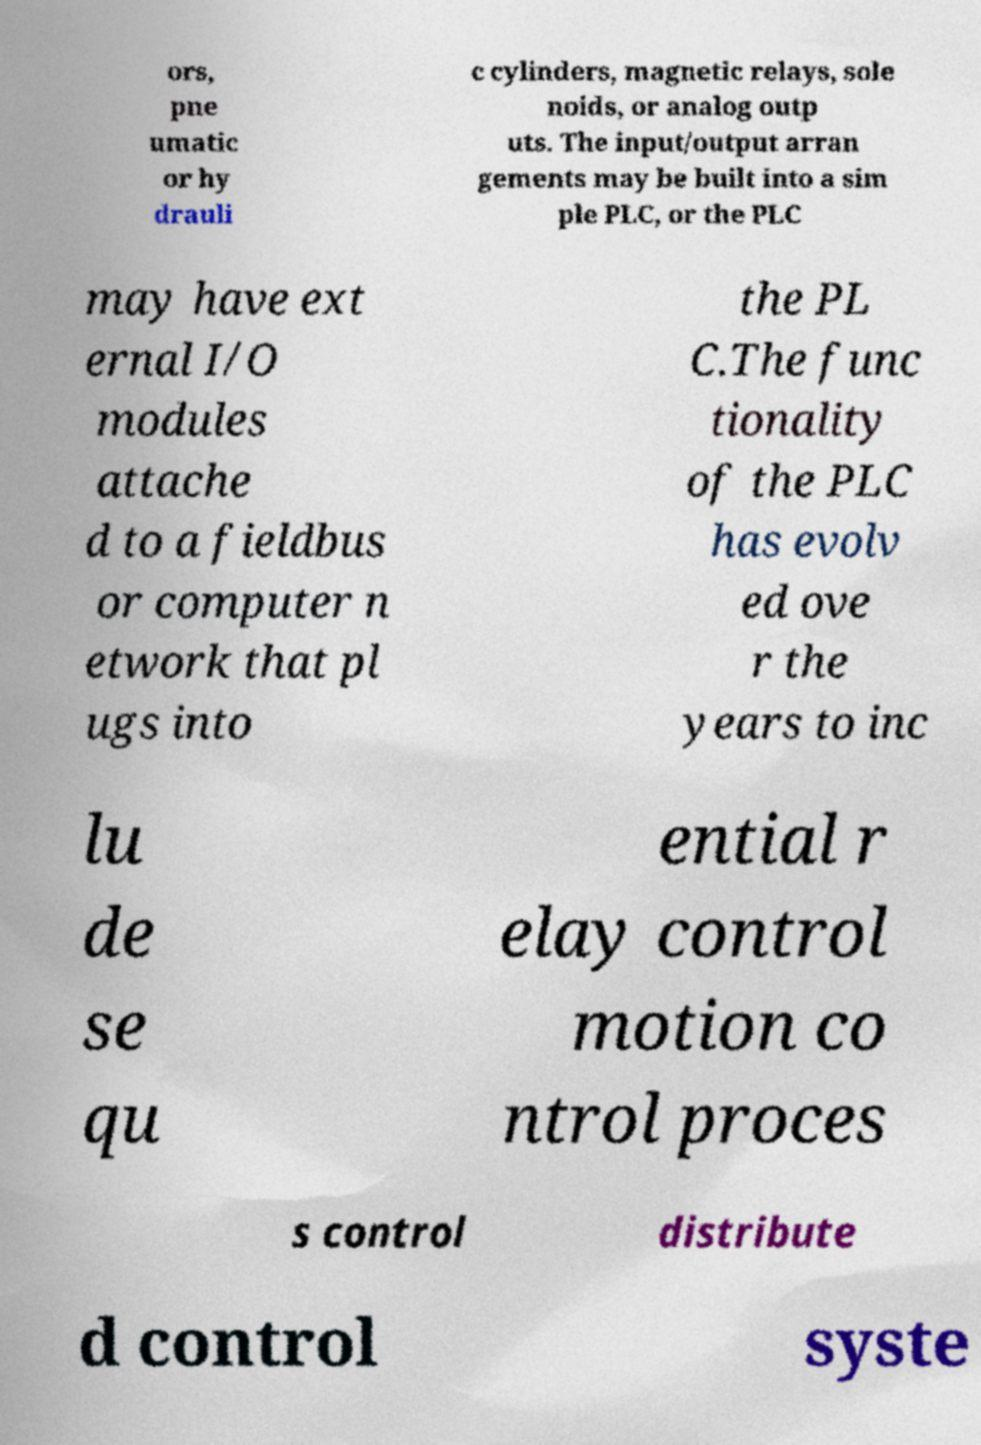Can you accurately transcribe the text from the provided image for me? ors, pne umatic or hy drauli c cylinders, magnetic relays, sole noids, or analog outp uts. The input/output arran gements may be built into a sim ple PLC, or the PLC may have ext ernal I/O modules attache d to a fieldbus or computer n etwork that pl ugs into the PL C.The func tionality of the PLC has evolv ed ove r the years to inc lu de se qu ential r elay control motion co ntrol proces s control distribute d control syste 